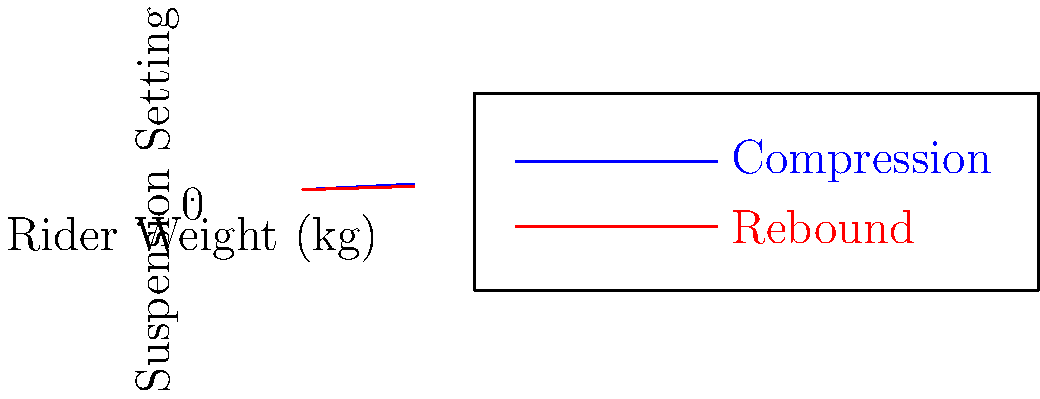Based on the graph showing compression and rebound settings for different rider weights, what would be the optimal suspension setup for a rider weighing 80 kg? Express your answer as (compression, rebound). To determine the optimal suspension setup for a rider weighing 80 kg, we need to follow these steps:

1. Identify the lines on the graph:
   - Blue line represents compression settings
   - Red line represents rebound settings

2. Find the compression setting for 80 kg:
   - Locate 80 kg on the x-axis
   - Move vertically up to the blue line
   - Read the corresponding y-value
   - The compression setting is approximately $0.05 * 80 + 2 = 6$

3. Find the rebound setting for 80 kg:
   - Locate 80 kg on the x-axis
   - Move vertically up to the red line
   - Read the corresponding y-value
   - The rebound setting is approximately $0.03 * 80 + 3 = 5.4$

4. Express the result as an ordered pair (compression, rebound)

Therefore, the optimal suspension setup for a rider weighing 80 kg is approximately (6, 5.4).
Answer: (6, 5.4) 